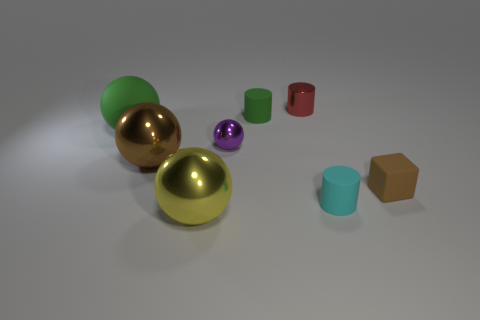Add 2 tiny red cylinders. How many objects exist? 10 Subtract all cylinders. How many objects are left? 5 Subtract 0 blue blocks. How many objects are left? 8 Subtract all small purple metallic balls. Subtract all yellow spheres. How many objects are left? 6 Add 6 small green rubber cylinders. How many small green rubber cylinders are left? 7 Add 3 large brown spheres. How many large brown spheres exist? 4 